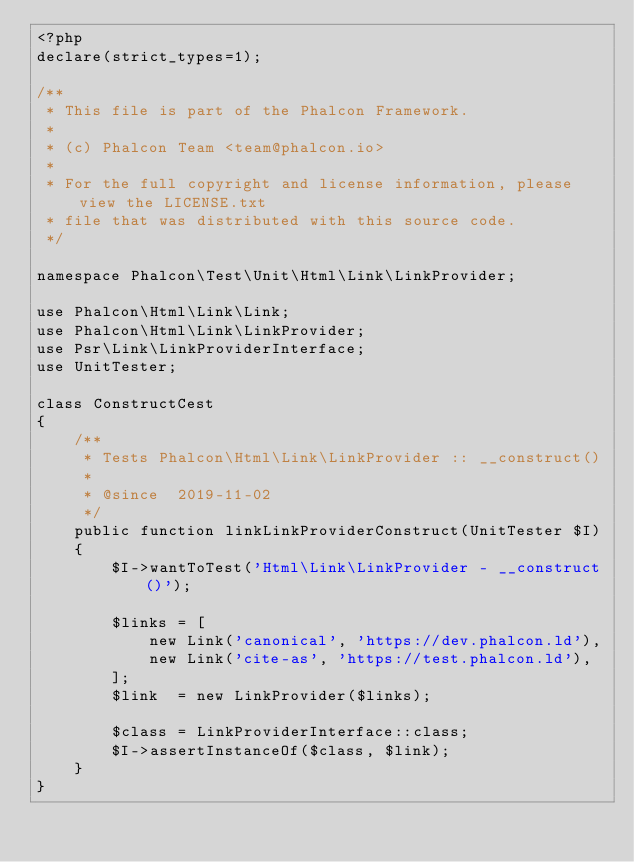Convert code to text. <code><loc_0><loc_0><loc_500><loc_500><_PHP_><?php
declare(strict_types=1);

/**
 * This file is part of the Phalcon Framework.
 *
 * (c) Phalcon Team <team@phalcon.io>
 *
 * For the full copyright and license information, please view the LICENSE.txt
 * file that was distributed with this source code.
 */

namespace Phalcon\Test\Unit\Html\Link\LinkProvider;

use Phalcon\Html\Link\Link;
use Phalcon\Html\Link\LinkProvider;
use Psr\Link\LinkProviderInterface;
use UnitTester;

class ConstructCest
{
    /**
     * Tests Phalcon\Html\Link\LinkProvider :: __construct()
     *
     * @since  2019-11-02
     */
    public function linkLinkProviderConstruct(UnitTester $I)
    {
        $I->wantToTest('Html\Link\LinkProvider - __construct()');

        $links = [
            new Link('canonical', 'https://dev.phalcon.ld'),
            new Link('cite-as', 'https://test.phalcon.ld'),
        ];
        $link  = new LinkProvider($links);

        $class = LinkProviderInterface::class;
        $I->assertInstanceOf($class, $link);
    }
}
</code> 